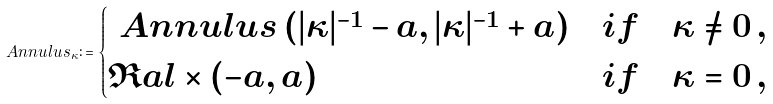<formula> <loc_0><loc_0><loc_500><loc_500>\ A n n u l u s _ { \kappa } \colon = \begin{cases} \ A n n u l u s \left ( | \kappa | ^ { - 1 } - a , | \kappa | ^ { - 1 } + a \right ) & i f \quad \kappa \not = 0 \, , \\ \Re a l \times ( - a , a ) & i f \quad \kappa = 0 \, , \end{cases}</formula> 